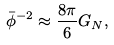<formula> <loc_0><loc_0><loc_500><loc_500>\bar { \phi } ^ { - 2 } \approx \frac { 8 \pi } { 6 } G _ { N } ,</formula> 